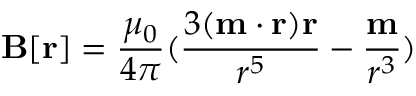<formula> <loc_0><loc_0><loc_500><loc_500>B [ r ] = { \frac { \mu _ { 0 } } { 4 \pi } } ( { \frac { 3 ( m \cdot r ) r } { r ^ { 5 } } } - { \frac { m } { r ^ { 3 } } } )</formula> 